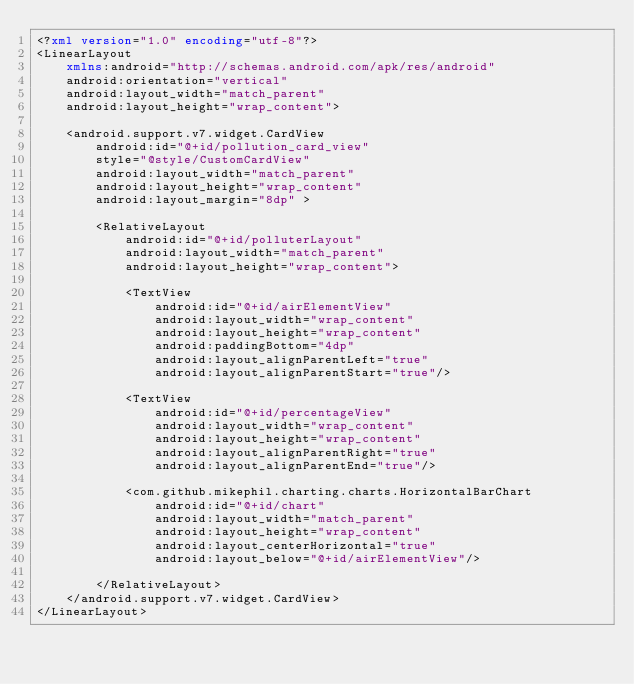<code> <loc_0><loc_0><loc_500><loc_500><_XML_><?xml version="1.0" encoding="utf-8"?>
<LinearLayout
    xmlns:android="http://schemas.android.com/apk/res/android"
    android:orientation="vertical"
    android:layout_width="match_parent"
    android:layout_height="wrap_content">

    <android.support.v7.widget.CardView
        android:id="@+id/pollution_card_view"
        style="@style/CustomCardView"
        android:layout_width="match_parent"
        android:layout_height="wrap_content"
        android:layout_margin="8dp" >

        <RelativeLayout
            android:id="@+id/polluterLayout"
            android:layout_width="match_parent"
            android:layout_height="wrap_content">

            <TextView
                android:id="@+id/airElementView"
                android:layout_width="wrap_content"
                android:layout_height="wrap_content"
                android:paddingBottom="4dp"
                android:layout_alignParentLeft="true"
                android:layout_alignParentStart="true"/>

            <TextView
                android:id="@+id/percentageView"
                android:layout_width="wrap_content"
                android:layout_height="wrap_content"
                android:layout_alignParentRight="true"
                android:layout_alignParentEnd="true"/>

            <com.github.mikephil.charting.charts.HorizontalBarChart
                android:id="@+id/chart"
                android:layout_width="match_parent"
                android:layout_height="wrap_content"
                android:layout_centerHorizontal="true"
                android:layout_below="@+id/airElementView"/>

        </RelativeLayout>
    </android.support.v7.widget.CardView>
</LinearLayout></code> 